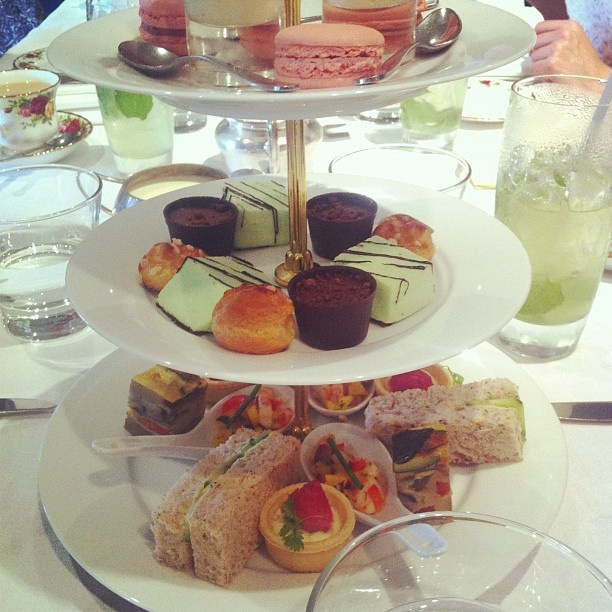Describe the objects in this image and their specific colors. I can see cup in gray, beige, tan, and khaki tones, bowl in gray, lightgray, darkgray, and beige tones, sandwich in gray, tan, brown, and maroon tones, cup in gray, ivory, darkgray, and lightgray tones, and sandwich in gray and tan tones in this image. 